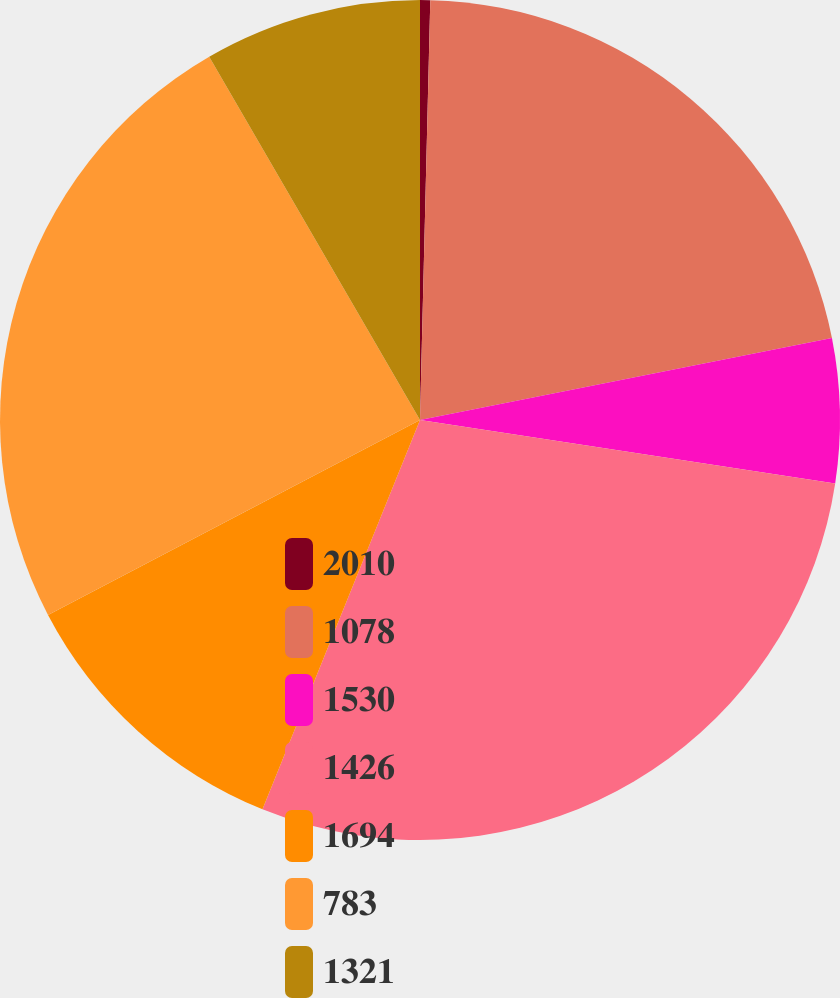Convert chart. <chart><loc_0><loc_0><loc_500><loc_500><pie_chart><fcel>2010<fcel>1078<fcel>1530<fcel>1426<fcel>1694<fcel>783<fcel>1321<nl><fcel>0.39%<fcel>21.49%<fcel>5.54%<fcel>28.71%<fcel>11.2%<fcel>24.32%<fcel>8.37%<nl></chart> 